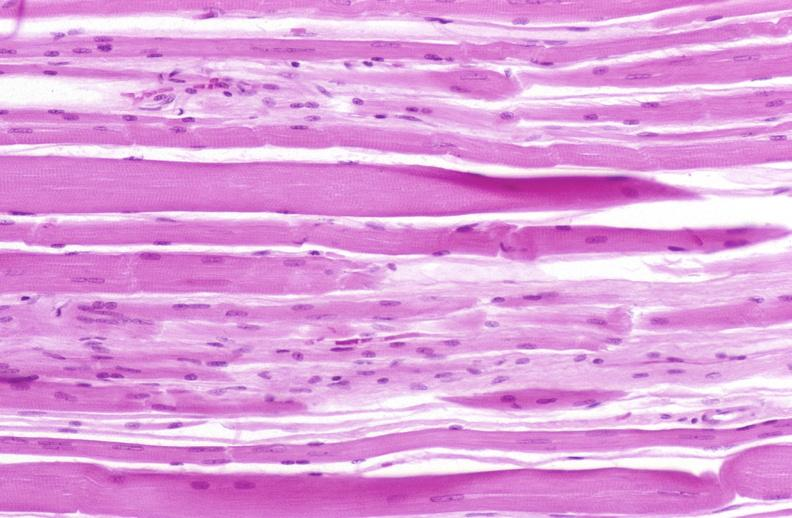s soft tissue present?
Answer the question using a single word or phrase. Yes 